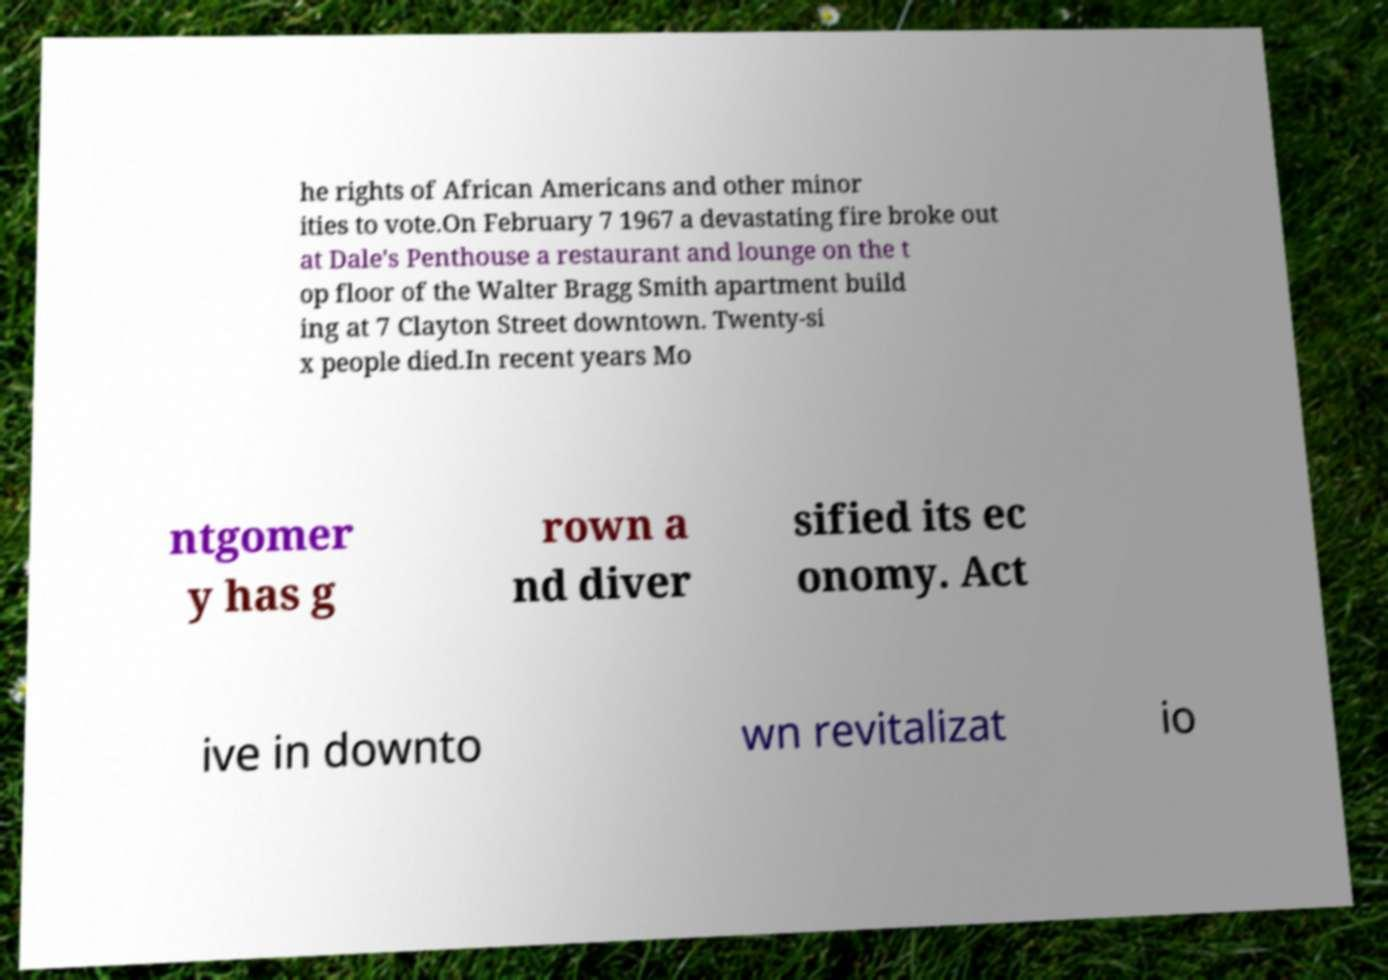Can you read and provide the text displayed in the image?This photo seems to have some interesting text. Can you extract and type it out for me? he rights of African Americans and other minor ities to vote.On February 7 1967 a devastating fire broke out at Dale's Penthouse a restaurant and lounge on the t op floor of the Walter Bragg Smith apartment build ing at 7 Clayton Street downtown. Twenty-si x people died.In recent years Mo ntgomer y has g rown a nd diver sified its ec onomy. Act ive in downto wn revitalizat io 